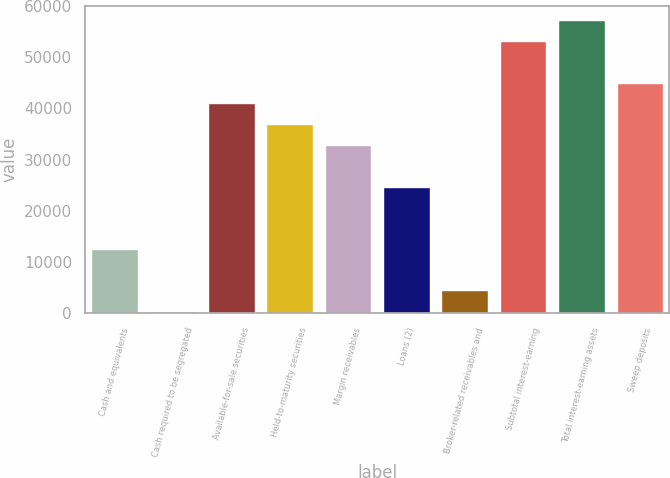Convert chart. <chart><loc_0><loc_0><loc_500><loc_500><bar_chart><fcel>Cash and equivalents<fcel>Cash required to be segregated<fcel>Available-for-sale securities<fcel>Held-to-maturity securities<fcel>Margin receivables<fcel>Loans (2)<fcel>Broker-related receivables and<fcel>Subtotal interest-earning<fcel>Total interest-earning assets<fcel>Sweep deposits<nl><fcel>12584.6<fcel>425<fcel>40957<fcel>36903.8<fcel>32850.6<fcel>24744.2<fcel>4478.2<fcel>53116.6<fcel>57169.8<fcel>45010.2<nl></chart> 